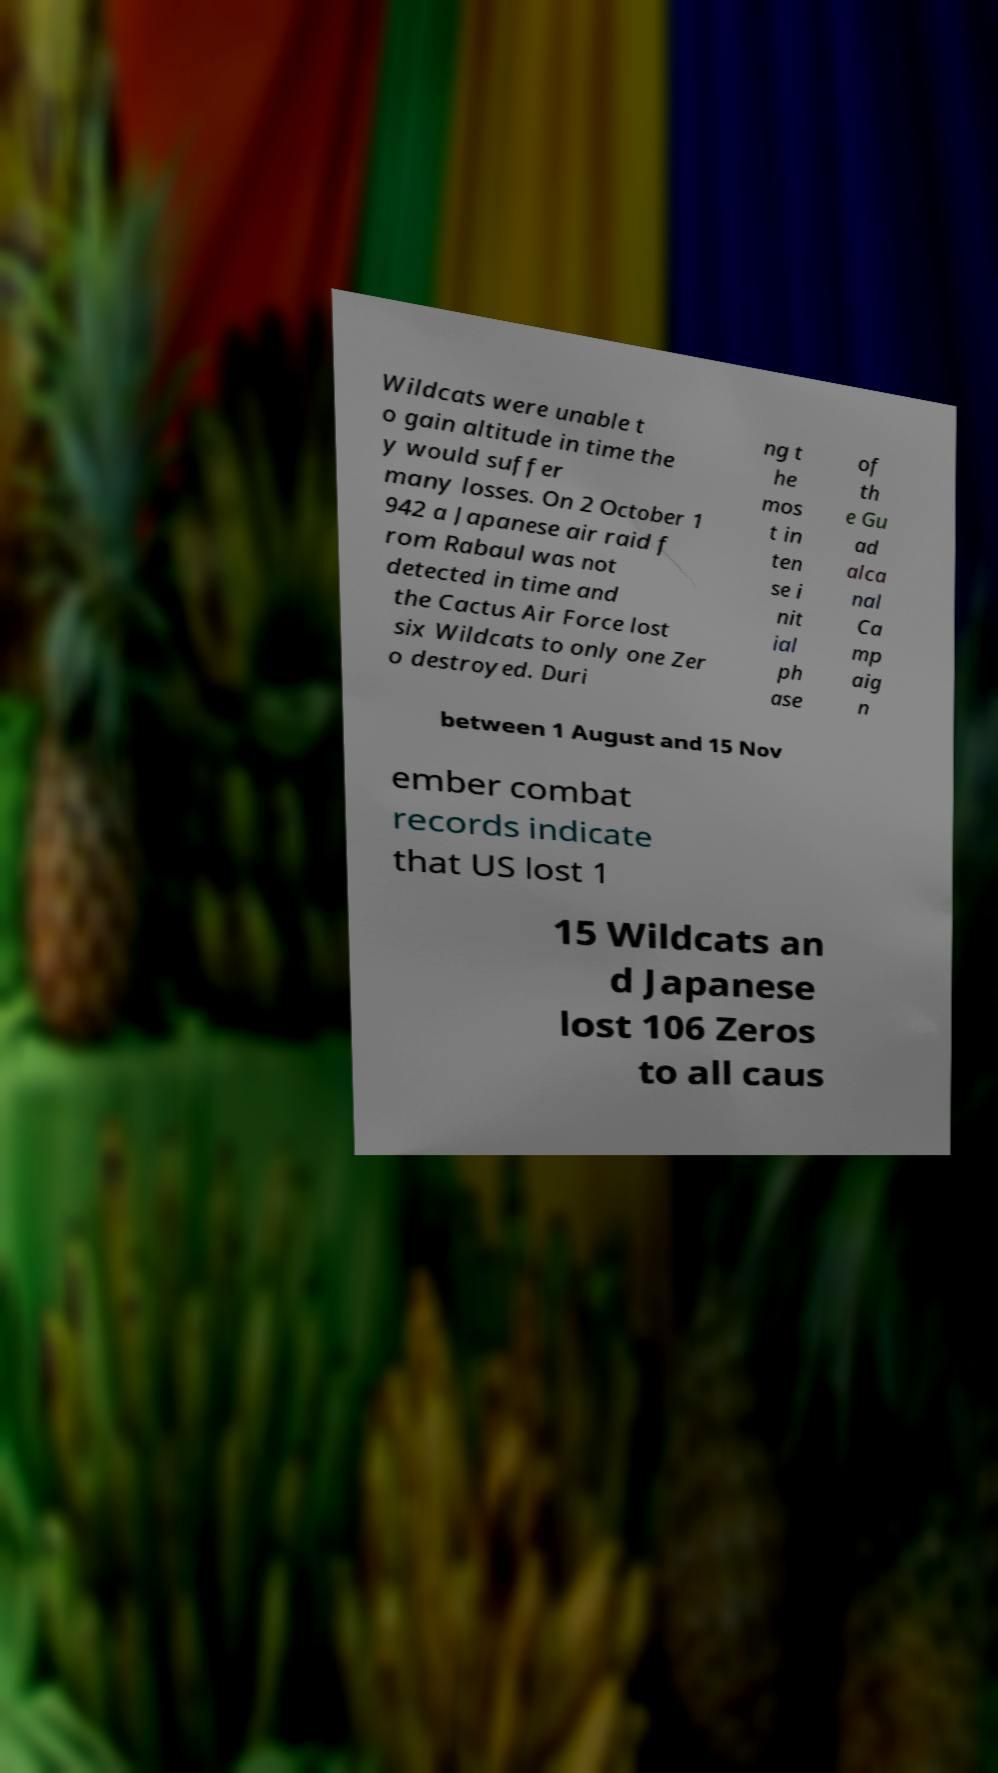Could you assist in decoding the text presented in this image and type it out clearly? Wildcats were unable t o gain altitude in time the y would suffer many losses. On 2 October 1 942 a Japanese air raid f rom Rabaul was not detected in time and the Cactus Air Force lost six Wildcats to only one Zer o destroyed. Duri ng t he mos t in ten se i nit ial ph ase of th e Gu ad alca nal Ca mp aig n between 1 August and 15 Nov ember combat records indicate that US lost 1 15 Wildcats an d Japanese lost 106 Zeros to all caus 